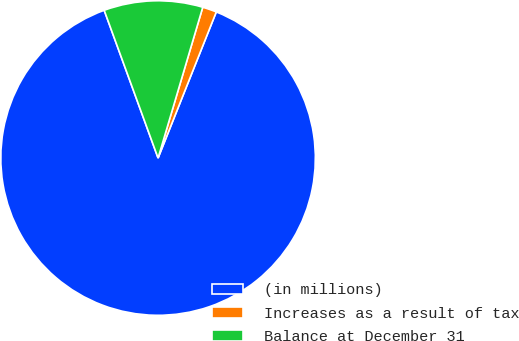Convert chart. <chart><loc_0><loc_0><loc_500><loc_500><pie_chart><fcel>(in millions)<fcel>Increases as a result of tax<fcel>Balance at December 31<nl><fcel>88.4%<fcel>1.45%<fcel>10.15%<nl></chart> 